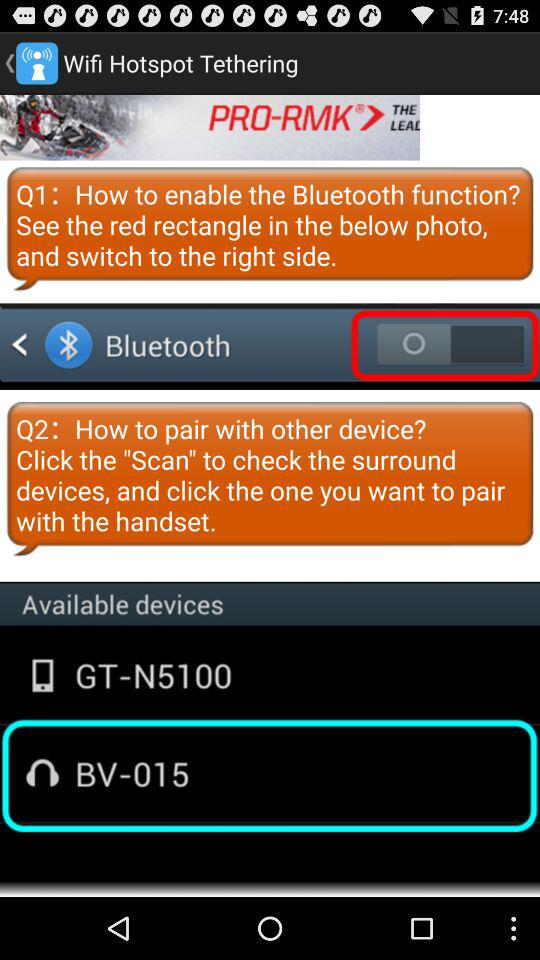How many items are available for pairing?
Answer the question using a single word or phrase. 2 